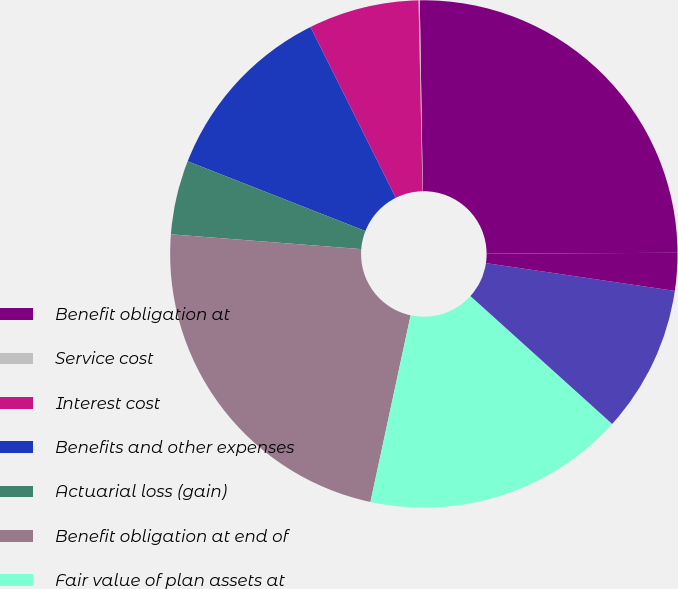Convert chart. <chart><loc_0><loc_0><loc_500><loc_500><pie_chart><fcel>Benefit obligation at<fcel>Service cost<fcel>Interest cost<fcel>Benefits and other expenses<fcel>Actuarial loss (gain)<fcel>Benefit obligation at end of<fcel>Fair value of plan assets at<fcel>Actual return on plan assets<fcel>Employer contributions<nl><fcel>25.18%<fcel>0.08%<fcel>7.04%<fcel>11.67%<fcel>4.72%<fcel>22.86%<fcel>16.69%<fcel>9.36%<fcel>2.4%<nl></chart> 